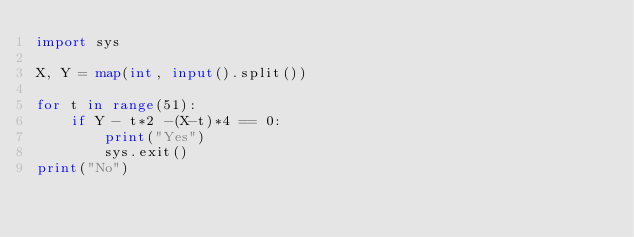Convert code to text. <code><loc_0><loc_0><loc_500><loc_500><_Python_>import sys

X, Y = map(int, input().split())

for t in range(51):
    if Y - t*2 -(X-t)*4 == 0:
        print("Yes")
        sys.exit()
print("No")</code> 